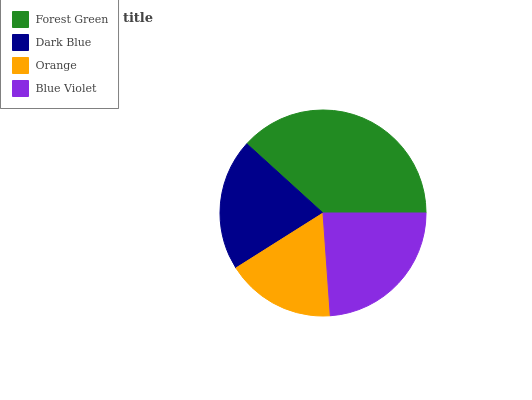Is Orange the minimum?
Answer yes or no. Yes. Is Forest Green the maximum?
Answer yes or no. Yes. Is Dark Blue the minimum?
Answer yes or no. No. Is Dark Blue the maximum?
Answer yes or no. No. Is Forest Green greater than Dark Blue?
Answer yes or no. Yes. Is Dark Blue less than Forest Green?
Answer yes or no. Yes. Is Dark Blue greater than Forest Green?
Answer yes or no. No. Is Forest Green less than Dark Blue?
Answer yes or no. No. Is Blue Violet the high median?
Answer yes or no. Yes. Is Dark Blue the low median?
Answer yes or no. Yes. Is Dark Blue the high median?
Answer yes or no. No. Is Forest Green the low median?
Answer yes or no. No. 